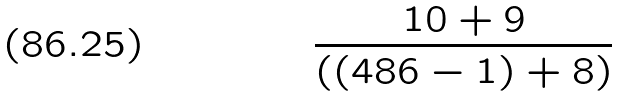<formula> <loc_0><loc_0><loc_500><loc_500>\frac { 1 0 + 9 } { ( ( 4 8 6 - 1 ) + 8 ) }</formula> 